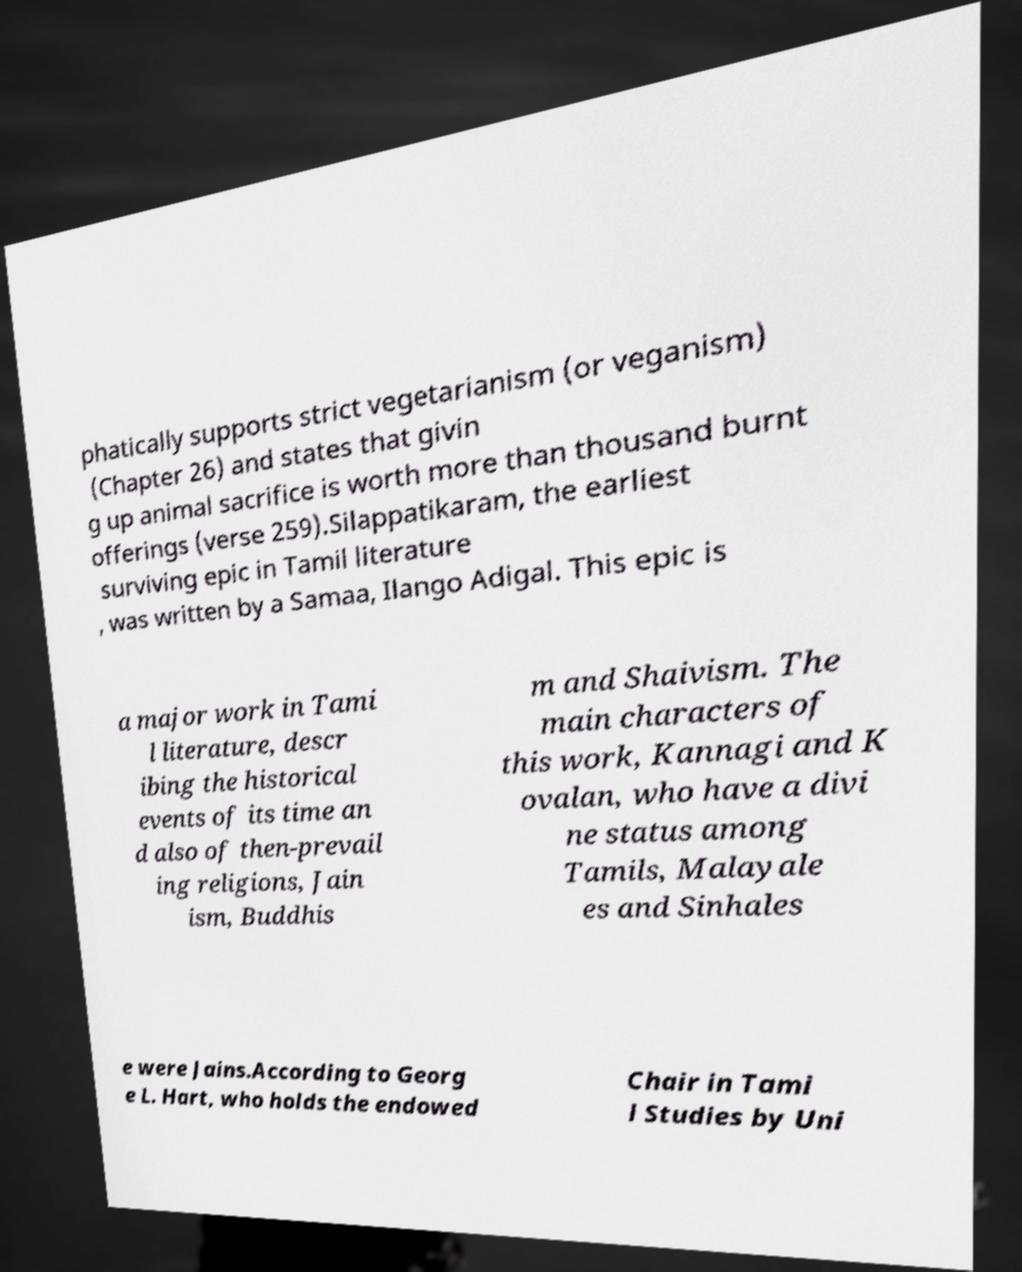Could you extract and type out the text from this image? phatically supports strict vegetarianism (or veganism) (Chapter 26) and states that givin g up animal sacrifice is worth more than thousand burnt offerings (verse 259).Silappatikaram, the earliest surviving epic in Tamil literature , was written by a Samaa, Ilango Adigal. This epic is a major work in Tami l literature, descr ibing the historical events of its time an d also of then-prevail ing religions, Jain ism, Buddhis m and Shaivism. The main characters of this work, Kannagi and K ovalan, who have a divi ne status among Tamils, Malayale es and Sinhales e were Jains.According to Georg e L. Hart, who holds the endowed Chair in Tami l Studies by Uni 